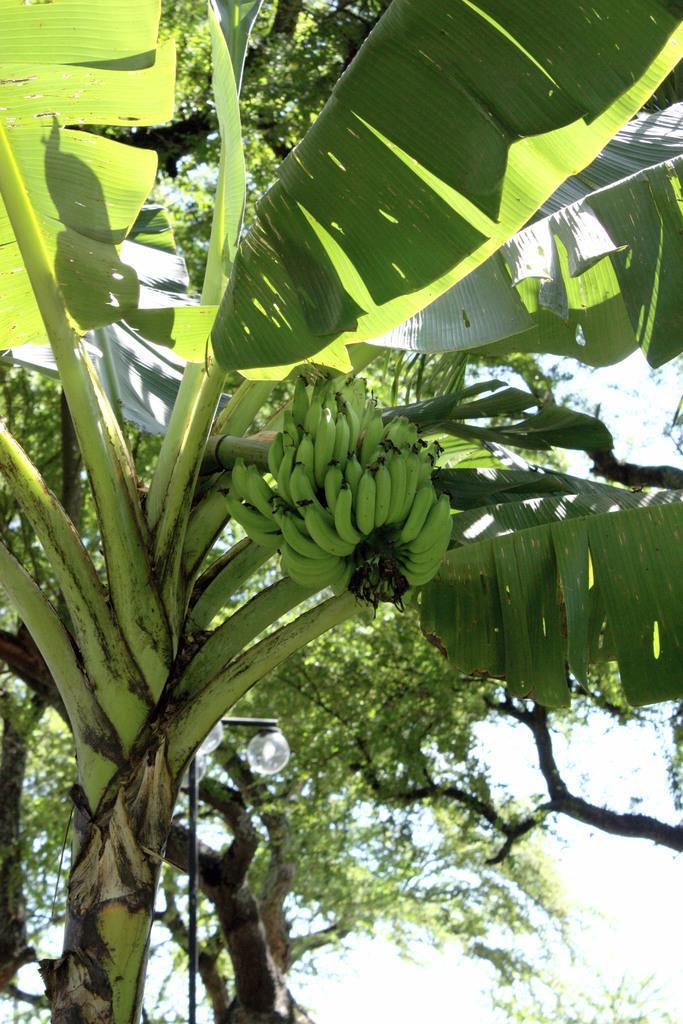In one or two sentences, can you explain what this image depicts? In this image in the front there is a banana tree. In the background there are trees. 